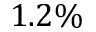<formula> <loc_0><loc_0><loc_500><loc_500>1 . 2 \%</formula> 